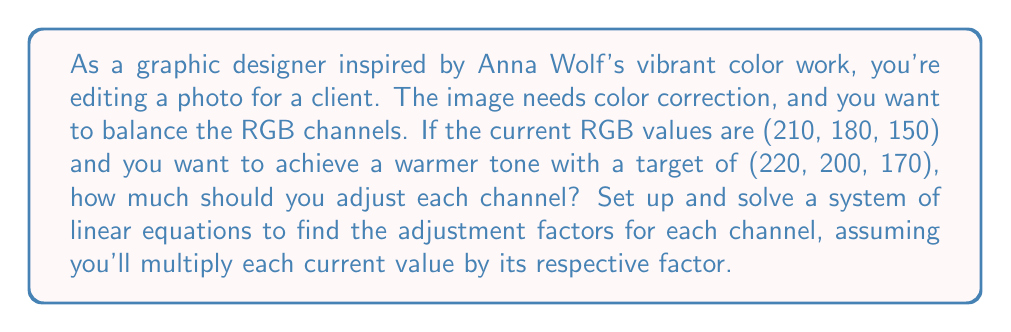Help me with this question. Let's approach this step-by-step:

1) Let $r$, $g$, and $b$ be the factors by which we'll multiply the red, green, and blue channels respectively.

2) We can set up a system of linear equations:

   $$\begin{cases}
   210r = 220 \\
   180g = 200 \\
   150b = 170
   \end{cases}$$

3) Now, let's solve each equation:

   For red: $210r = 220$
   $$r = \frac{220}{210} = \frac{11}{10.5} \approx 1.0476$$

   For green: $180g = 200$
   $$g = \frac{200}{180} = \frac{10}{9} \approx 1.1111$$

   For blue: $150b = 170$
   $$b = \frac{170}{150} = \frac{17}{15} \approx 1.1333$$

4) These factors tell us how much to multiply each channel by:
   - Red: Multiply by approximately 1.0476
   - Green: Multiply by approximately 1.1111
   - Blue: Multiply by approximately 1.1333

5) To get the adjustment amount, we subtract 1 from each factor:
   - Red: 1.0476 - 1 = 0.0476 (increase by 4.76%)
   - Green: 1.1111 - 1 = 0.1111 (increase by 11.11%)
   - Blue: 1.1333 - 1 = 0.1333 (increase by 13.33%)
Answer: Red: +4.76%, Green: +11.11%, Blue: +13.33% 